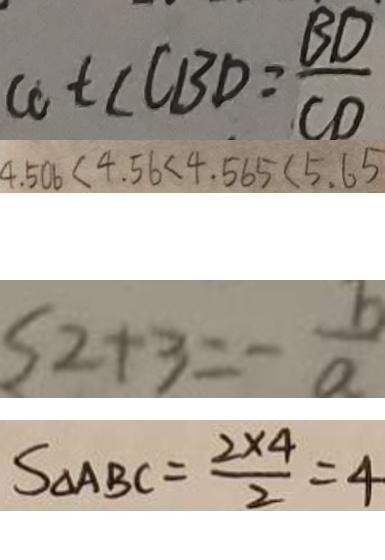Convert formula to latex. <formula><loc_0><loc_0><loc_500><loc_500>\cot \angle C B D = \frac { B D } { C D } 
 4 . 5 0 6 < 4 . 5 6 < 4 . 5 6 5 < 5 . 6 5 
 2 + 3 = - \frac { b } { a } 
 S _ { \Delta A B C } = \frac { 2 \times 4 } { 2 } = 4</formula> 